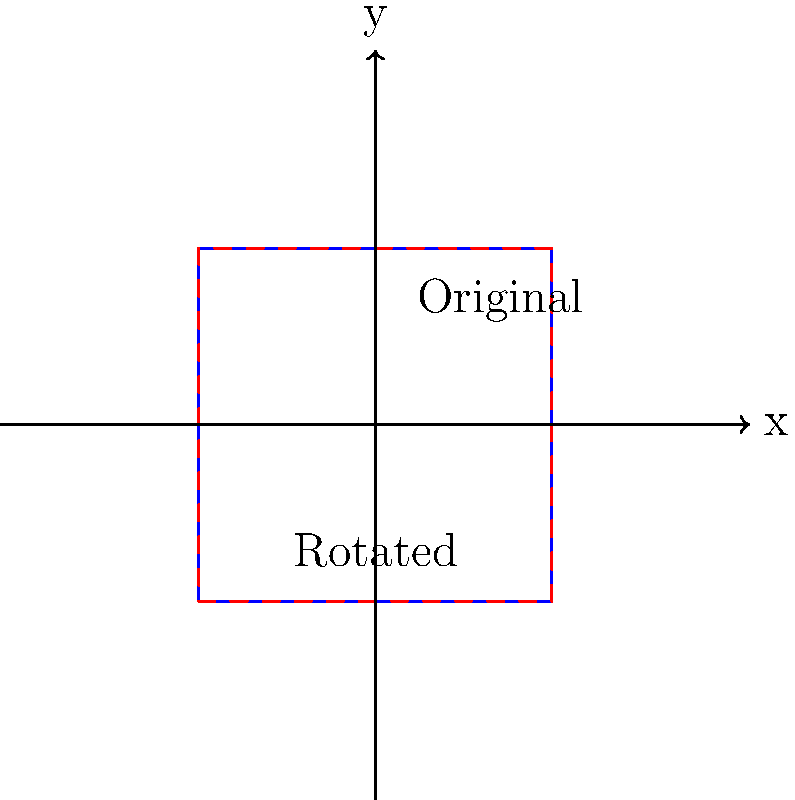A hospital is considering rotating its square-shaped floor plan by 90 degrees counterclockwise to optimize space utilization. If the original floor plan has coordinates $A(0,0)$, $B(1,0)$, $C(1,1)$, and $D(0,1)$, what will be the coordinates of point $C$ after the rotation? To solve this problem, we need to apply the principles of rotational transformation in geometry. Here's a step-by-step explanation:

1) The rotation matrix for a 90-degree counterclockwise rotation is:
   $$\begin{pmatrix} \cos 90° & -\sin 90° \\ \sin 90° & \cos 90° \end{pmatrix} = \begin{pmatrix} 0 & -1 \\ 1 & 0 \end{pmatrix}$$

2) The original coordinates of point $C$ are $(1,1)$.

3) To find the new coordinates, we multiply the rotation matrix by the original coordinates:
   $$\begin{pmatrix} 0 & -1 \\ 1 & 0 \end{pmatrix} \begin{pmatrix} 1 \\ 1 \end{pmatrix} = \begin{pmatrix} -1 \\ 1 \end{pmatrix}$$

4) Therefore, after the 90-degree counterclockwise rotation, the coordinates of point $C$ will be $(-1,1)$.

This transformation optimizes space by reorienting the floor plan, which could potentially lead to more efficient use of the hospital space and possibly reduce operational costs, indirectly addressing the concern of rising healthcare costs.
Answer: $(-1,1)$ 